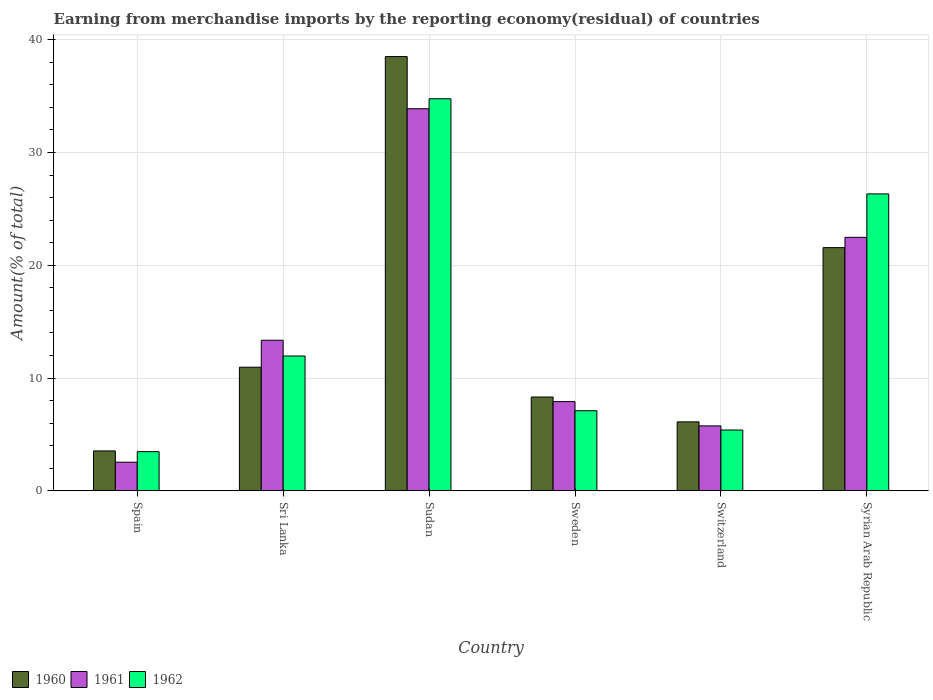Are the number of bars per tick equal to the number of legend labels?
Give a very brief answer. Yes. How many bars are there on the 3rd tick from the left?
Your answer should be very brief. 3. What is the label of the 2nd group of bars from the left?
Provide a short and direct response. Sri Lanka. In how many cases, is the number of bars for a given country not equal to the number of legend labels?
Ensure brevity in your answer.  0. What is the percentage of amount earned from merchandise imports in 1960 in Sudan?
Provide a short and direct response. 38.5. Across all countries, what is the maximum percentage of amount earned from merchandise imports in 1960?
Give a very brief answer. 38.5. Across all countries, what is the minimum percentage of amount earned from merchandise imports in 1961?
Your answer should be compact. 2.54. In which country was the percentage of amount earned from merchandise imports in 1961 maximum?
Provide a succinct answer. Sudan. In which country was the percentage of amount earned from merchandise imports in 1961 minimum?
Your response must be concise. Spain. What is the total percentage of amount earned from merchandise imports in 1962 in the graph?
Provide a succinct answer. 89. What is the difference between the percentage of amount earned from merchandise imports in 1961 in Sri Lanka and that in Sweden?
Your answer should be compact. 5.44. What is the difference between the percentage of amount earned from merchandise imports in 1962 in Sudan and the percentage of amount earned from merchandise imports in 1961 in Sweden?
Ensure brevity in your answer.  26.86. What is the average percentage of amount earned from merchandise imports in 1962 per country?
Keep it short and to the point. 14.83. What is the difference between the percentage of amount earned from merchandise imports of/in 1962 and percentage of amount earned from merchandise imports of/in 1961 in Sweden?
Offer a very short reply. -0.81. In how many countries, is the percentage of amount earned from merchandise imports in 1961 greater than 10 %?
Ensure brevity in your answer.  3. What is the ratio of the percentage of amount earned from merchandise imports in 1960 in Sudan to that in Switzerland?
Make the answer very short. 6.3. What is the difference between the highest and the second highest percentage of amount earned from merchandise imports in 1961?
Your answer should be very brief. 20.53. What is the difference between the highest and the lowest percentage of amount earned from merchandise imports in 1961?
Ensure brevity in your answer.  31.34. In how many countries, is the percentage of amount earned from merchandise imports in 1962 greater than the average percentage of amount earned from merchandise imports in 1962 taken over all countries?
Offer a terse response. 2. Is the sum of the percentage of amount earned from merchandise imports in 1961 in Spain and Sweden greater than the maximum percentage of amount earned from merchandise imports in 1962 across all countries?
Provide a short and direct response. No. What does the 3rd bar from the left in Sudan represents?
Give a very brief answer. 1962. What does the 3rd bar from the right in Sweden represents?
Your answer should be compact. 1960. Are all the bars in the graph horizontal?
Your response must be concise. No. How many countries are there in the graph?
Your answer should be very brief. 6. What is the difference between two consecutive major ticks on the Y-axis?
Provide a succinct answer. 10. Does the graph contain grids?
Give a very brief answer. Yes. Where does the legend appear in the graph?
Your answer should be very brief. Bottom left. How many legend labels are there?
Give a very brief answer. 3. What is the title of the graph?
Make the answer very short. Earning from merchandise imports by the reporting economy(residual) of countries. What is the label or title of the X-axis?
Your answer should be very brief. Country. What is the label or title of the Y-axis?
Offer a terse response. Amount(% of total). What is the Amount(% of total) in 1960 in Spain?
Offer a very short reply. 3.54. What is the Amount(% of total) in 1961 in Spain?
Your answer should be very brief. 2.54. What is the Amount(% of total) of 1962 in Spain?
Offer a very short reply. 3.47. What is the Amount(% of total) in 1960 in Sri Lanka?
Your answer should be very brief. 10.96. What is the Amount(% of total) of 1961 in Sri Lanka?
Ensure brevity in your answer.  13.35. What is the Amount(% of total) in 1962 in Sri Lanka?
Give a very brief answer. 11.95. What is the Amount(% of total) of 1960 in Sudan?
Provide a succinct answer. 38.5. What is the Amount(% of total) of 1961 in Sudan?
Keep it short and to the point. 33.88. What is the Amount(% of total) in 1962 in Sudan?
Make the answer very short. 34.76. What is the Amount(% of total) of 1960 in Sweden?
Keep it short and to the point. 8.32. What is the Amount(% of total) of 1961 in Sweden?
Your answer should be compact. 7.91. What is the Amount(% of total) of 1962 in Sweden?
Provide a succinct answer. 7.1. What is the Amount(% of total) of 1960 in Switzerland?
Ensure brevity in your answer.  6.11. What is the Amount(% of total) of 1961 in Switzerland?
Your answer should be compact. 5.76. What is the Amount(% of total) in 1962 in Switzerland?
Offer a terse response. 5.39. What is the Amount(% of total) in 1960 in Syrian Arab Republic?
Give a very brief answer. 21.56. What is the Amount(% of total) in 1961 in Syrian Arab Republic?
Provide a succinct answer. 22.48. What is the Amount(% of total) in 1962 in Syrian Arab Republic?
Offer a terse response. 26.33. Across all countries, what is the maximum Amount(% of total) in 1960?
Your answer should be compact. 38.5. Across all countries, what is the maximum Amount(% of total) in 1961?
Ensure brevity in your answer.  33.88. Across all countries, what is the maximum Amount(% of total) of 1962?
Your answer should be compact. 34.76. Across all countries, what is the minimum Amount(% of total) of 1960?
Your answer should be very brief. 3.54. Across all countries, what is the minimum Amount(% of total) in 1961?
Your response must be concise. 2.54. Across all countries, what is the minimum Amount(% of total) in 1962?
Make the answer very short. 3.47. What is the total Amount(% of total) in 1960 in the graph?
Offer a very short reply. 88.99. What is the total Amount(% of total) in 1961 in the graph?
Offer a very short reply. 85.9. What is the total Amount(% of total) in 1962 in the graph?
Make the answer very short. 89. What is the difference between the Amount(% of total) of 1960 in Spain and that in Sri Lanka?
Provide a short and direct response. -7.42. What is the difference between the Amount(% of total) in 1961 in Spain and that in Sri Lanka?
Your answer should be very brief. -10.81. What is the difference between the Amount(% of total) in 1962 in Spain and that in Sri Lanka?
Your answer should be very brief. -8.48. What is the difference between the Amount(% of total) of 1960 in Spain and that in Sudan?
Your response must be concise. -34.97. What is the difference between the Amount(% of total) of 1961 in Spain and that in Sudan?
Your response must be concise. -31.34. What is the difference between the Amount(% of total) of 1962 in Spain and that in Sudan?
Your response must be concise. -31.29. What is the difference between the Amount(% of total) in 1960 in Spain and that in Sweden?
Offer a very short reply. -4.78. What is the difference between the Amount(% of total) of 1961 in Spain and that in Sweden?
Your response must be concise. -5.37. What is the difference between the Amount(% of total) of 1962 in Spain and that in Sweden?
Offer a terse response. -3.63. What is the difference between the Amount(% of total) in 1960 in Spain and that in Switzerland?
Provide a short and direct response. -2.58. What is the difference between the Amount(% of total) in 1961 in Spain and that in Switzerland?
Give a very brief answer. -3.22. What is the difference between the Amount(% of total) of 1962 in Spain and that in Switzerland?
Offer a very short reply. -1.92. What is the difference between the Amount(% of total) of 1960 in Spain and that in Syrian Arab Republic?
Your answer should be compact. -18.03. What is the difference between the Amount(% of total) of 1961 in Spain and that in Syrian Arab Republic?
Your response must be concise. -19.94. What is the difference between the Amount(% of total) of 1962 in Spain and that in Syrian Arab Republic?
Provide a succinct answer. -22.86. What is the difference between the Amount(% of total) of 1960 in Sri Lanka and that in Sudan?
Give a very brief answer. -27.55. What is the difference between the Amount(% of total) of 1961 in Sri Lanka and that in Sudan?
Provide a short and direct response. -20.53. What is the difference between the Amount(% of total) of 1962 in Sri Lanka and that in Sudan?
Offer a very short reply. -22.81. What is the difference between the Amount(% of total) in 1960 in Sri Lanka and that in Sweden?
Offer a very short reply. 2.64. What is the difference between the Amount(% of total) of 1961 in Sri Lanka and that in Sweden?
Make the answer very short. 5.44. What is the difference between the Amount(% of total) of 1962 in Sri Lanka and that in Sweden?
Make the answer very short. 4.85. What is the difference between the Amount(% of total) in 1960 in Sri Lanka and that in Switzerland?
Make the answer very short. 4.85. What is the difference between the Amount(% of total) in 1961 in Sri Lanka and that in Switzerland?
Make the answer very short. 7.59. What is the difference between the Amount(% of total) of 1962 in Sri Lanka and that in Switzerland?
Keep it short and to the point. 6.56. What is the difference between the Amount(% of total) of 1960 in Sri Lanka and that in Syrian Arab Republic?
Offer a terse response. -10.61. What is the difference between the Amount(% of total) of 1961 in Sri Lanka and that in Syrian Arab Republic?
Ensure brevity in your answer.  -9.13. What is the difference between the Amount(% of total) in 1962 in Sri Lanka and that in Syrian Arab Republic?
Keep it short and to the point. -14.37. What is the difference between the Amount(% of total) of 1960 in Sudan and that in Sweden?
Give a very brief answer. 30.19. What is the difference between the Amount(% of total) in 1961 in Sudan and that in Sweden?
Provide a short and direct response. 25.97. What is the difference between the Amount(% of total) of 1962 in Sudan and that in Sweden?
Offer a terse response. 27.66. What is the difference between the Amount(% of total) of 1960 in Sudan and that in Switzerland?
Provide a succinct answer. 32.39. What is the difference between the Amount(% of total) of 1961 in Sudan and that in Switzerland?
Make the answer very short. 28.12. What is the difference between the Amount(% of total) of 1962 in Sudan and that in Switzerland?
Give a very brief answer. 29.37. What is the difference between the Amount(% of total) in 1960 in Sudan and that in Syrian Arab Republic?
Give a very brief answer. 16.94. What is the difference between the Amount(% of total) in 1961 in Sudan and that in Syrian Arab Republic?
Offer a very short reply. 11.4. What is the difference between the Amount(% of total) of 1962 in Sudan and that in Syrian Arab Republic?
Make the answer very short. 8.44. What is the difference between the Amount(% of total) in 1960 in Sweden and that in Switzerland?
Offer a terse response. 2.2. What is the difference between the Amount(% of total) of 1961 in Sweden and that in Switzerland?
Offer a terse response. 2.15. What is the difference between the Amount(% of total) of 1962 in Sweden and that in Switzerland?
Ensure brevity in your answer.  1.71. What is the difference between the Amount(% of total) of 1960 in Sweden and that in Syrian Arab Republic?
Give a very brief answer. -13.25. What is the difference between the Amount(% of total) in 1961 in Sweden and that in Syrian Arab Republic?
Give a very brief answer. -14.57. What is the difference between the Amount(% of total) in 1962 in Sweden and that in Syrian Arab Republic?
Make the answer very short. -19.23. What is the difference between the Amount(% of total) of 1960 in Switzerland and that in Syrian Arab Republic?
Make the answer very short. -15.45. What is the difference between the Amount(% of total) in 1961 in Switzerland and that in Syrian Arab Republic?
Your answer should be compact. -16.72. What is the difference between the Amount(% of total) in 1962 in Switzerland and that in Syrian Arab Republic?
Provide a succinct answer. -20.94. What is the difference between the Amount(% of total) of 1960 in Spain and the Amount(% of total) of 1961 in Sri Lanka?
Make the answer very short. -9.81. What is the difference between the Amount(% of total) of 1960 in Spain and the Amount(% of total) of 1962 in Sri Lanka?
Give a very brief answer. -8.42. What is the difference between the Amount(% of total) in 1961 in Spain and the Amount(% of total) in 1962 in Sri Lanka?
Offer a very short reply. -9.42. What is the difference between the Amount(% of total) of 1960 in Spain and the Amount(% of total) of 1961 in Sudan?
Provide a short and direct response. -30.34. What is the difference between the Amount(% of total) in 1960 in Spain and the Amount(% of total) in 1962 in Sudan?
Give a very brief answer. -31.23. What is the difference between the Amount(% of total) of 1961 in Spain and the Amount(% of total) of 1962 in Sudan?
Keep it short and to the point. -32.23. What is the difference between the Amount(% of total) in 1960 in Spain and the Amount(% of total) in 1961 in Sweden?
Give a very brief answer. -4.37. What is the difference between the Amount(% of total) of 1960 in Spain and the Amount(% of total) of 1962 in Sweden?
Offer a very short reply. -3.56. What is the difference between the Amount(% of total) of 1961 in Spain and the Amount(% of total) of 1962 in Sweden?
Provide a succinct answer. -4.56. What is the difference between the Amount(% of total) in 1960 in Spain and the Amount(% of total) in 1961 in Switzerland?
Offer a terse response. -2.22. What is the difference between the Amount(% of total) in 1960 in Spain and the Amount(% of total) in 1962 in Switzerland?
Your answer should be compact. -1.85. What is the difference between the Amount(% of total) of 1961 in Spain and the Amount(% of total) of 1962 in Switzerland?
Ensure brevity in your answer.  -2.85. What is the difference between the Amount(% of total) of 1960 in Spain and the Amount(% of total) of 1961 in Syrian Arab Republic?
Keep it short and to the point. -18.94. What is the difference between the Amount(% of total) of 1960 in Spain and the Amount(% of total) of 1962 in Syrian Arab Republic?
Keep it short and to the point. -22.79. What is the difference between the Amount(% of total) of 1961 in Spain and the Amount(% of total) of 1962 in Syrian Arab Republic?
Provide a succinct answer. -23.79. What is the difference between the Amount(% of total) in 1960 in Sri Lanka and the Amount(% of total) in 1961 in Sudan?
Make the answer very short. -22.92. What is the difference between the Amount(% of total) in 1960 in Sri Lanka and the Amount(% of total) in 1962 in Sudan?
Keep it short and to the point. -23.8. What is the difference between the Amount(% of total) in 1961 in Sri Lanka and the Amount(% of total) in 1962 in Sudan?
Make the answer very short. -21.41. What is the difference between the Amount(% of total) in 1960 in Sri Lanka and the Amount(% of total) in 1961 in Sweden?
Your answer should be very brief. 3.05. What is the difference between the Amount(% of total) in 1960 in Sri Lanka and the Amount(% of total) in 1962 in Sweden?
Make the answer very short. 3.86. What is the difference between the Amount(% of total) of 1961 in Sri Lanka and the Amount(% of total) of 1962 in Sweden?
Ensure brevity in your answer.  6.25. What is the difference between the Amount(% of total) of 1960 in Sri Lanka and the Amount(% of total) of 1961 in Switzerland?
Offer a very short reply. 5.2. What is the difference between the Amount(% of total) of 1960 in Sri Lanka and the Amount(% of total) of 1962 in Switzerland?
Give a very brief answer. 5.57. What is the difference between the Amount(% of total) of 1961 in Sri Lanka and the Amount(% of total) of 1962 in Switzerland?
Ensure brevity in your answer.  7.96. What is the difference between the Amount(% of total) in 1960 in Sri Lanka and the Amount(% of total) in 1961 in Syrian Arab Republic?
Make the answer very short. -11.52. What is the difference between the Amount(% of total) of 1960 in Sri Lanka and the Amount(% of total) of 1962 in Syrian Arab Republic?
Offer a terse response. -15.37. What is the difference between the Amount(% of total) in 1961 in Sri Lanka and the Amount(% of total) in 1962 in Syrian Arab Republic?
Keep it short and to the point. -12.98. What is the difference between the Amount(% of total) in 1960 in Sudan and the Amount(% of total) in 1961 in Sweden?
Your answer should be compact. 30.6. What is the difference between the Amount(% of total) in 1960 in Sudan and the Amount(% of total) in 1962 in Sweden?
Offer a terse response. 31.4. What is the difference between the Amount(% of total) in 1961 in Sudan and the Amount(% of total) in 1962 in Sweden?
Give a very brief answer. 26.78. What is the difference between the Amount(% of total) in 1960 in Sudan and the Amount(% of total) in 1961 in Switzerland?
Provide a short and direct response. 32.75. What is the difference between the Amount(% of total) of 1960 in Sudan and the Amount(% of total) of 1962 in Switzerland?
Make the answer very short. 33.11. What is the difference between the Amount(% of total) of 1961 in Sudan and the Amount(% of total) of 1962 in Switzerland?
Offer a very short reply. 28.49. What is the difference between the Amount(% of total) of 1960 in Sudan and the Amount(% of total) of 1961 in Syrian Arab Republic?
Your answer should be very brief. 16.03. What is the difference between the Amount(% of total) in 1960 in Sudan and the Amount(% of total) in 1962 in Syrian Arab Republic?
Provide a short and direct response. 12.18. What is the difference between the Amount(% of total) of 1961 in Sudan and the Amount(% of total) of 1962 in Syrian Arab Republic?
Provide a short and direct response. 7.55. What is the difference between the Amount(% of total) in 1960 in Sweden and the Amount(% of total) in 1961 in Switzerland?
Offer a very short reply. 2.56. What is the difference between the Amount(% of total) in 1960 in Sweden and the Amount(% of total) in 1962 in Switzerland?
Provide a short and direct response. 2.93. What is the difference between the Amount(% of total) of 1961 in Sweden and the Amount(% of total) of 1962 in Switzerland?
Offer a very short reply. 2.52. What is the difference between the Amount(% of total) of 1960 in Sweden and the Amount(% of total) of 1961 in Syrian Arab Republic?
Your answer should be very brief. -14.16. What is the difference between the Amount(% of total) in 1960 in Sweden and the Amount(% of total) in 1962 in Syrian Arab Republic?
Offer a very short reply. -18.01. What is the difference between the Amount(% of total) of 1961 in Sweden and the Amount(% of total) of 1962 in Syrian Arab Republic?
Ensure brevity in your answer.  -18.42. What is the difference between the Amount(% of total) in 1960 in Switzerland and the Amount(% of total) in 1961 in Syrian Arab Republic?
Make the answer very short. -16.36. What is the difference between the Amount(% of total) of 1960 in Switzerland and the Amount(% of total) of 1962 in Syrian Arab Republic?
Ensure brevity in your answer.  -20.21. What is the difference between the Amount(% of total) in 1961 in Switzerland and the Amount(% of total) in 1962 in Syrian Arab Republic?
Ensure brevity in your answer.  -20.57. What is the average Amount(% of total) in 1960 per country?
Give a very brief answer. 14.83. What is the average Amount(% of total) in 1961 per country?
Ensure brevity in your answer.  14.32. What is the average Amount(% of total) in 1962 per country?
Offer a very short reply. 14.83. What is the difference between the Amount(% of total) in 1960 and Amount(% of total) in 1961 in Spain?
Your response must be concise. 1. What is the difference between the Amount(% of total) of 1960 and Amount(% of total) of 1962 in Spain?
Your response must be concise. 0.07. What is the difference between the Amount(% of total) of 1961 and Amount(% of total) of 1962 in Spain?
Make the answer very short. -0.94. What is the difference between the Amount(% of total) in 1960 and Amount(% of total) in 1961 in Sri Lanka?
Offer a very short reply. -2.39. What is the difference between the Amount(% of total) of 1960 and Amount(% of total) of 1962 in Sri Lanka?
Keep it short and to the point. -0.99. What is the difference between the Amount(% of total) of 1961 and Amount(% of total) of 1962 in Sri Lanka?
Your answer should be very brief. 1.4. What is the difference between the Amount(% of total) of 1960 and Amount(% of total) of 1961 in Sudan?
Your response must be concise. 4.63. What is the difference between the Amount(% of total) in 1960 and Amount(% of total) in 1962 in Sudan?
Keep it short and to the point. 3.74. What is the difference between the Amount(% of total) in 1961 and Amount(% of total) in 1962 in Sudan?
Your answer should be compact. -0.89. What is the difference between the Amount(% of total) in 1960 and Amount(% of total) in 1961 in Sweden?
Offer a terse response. 0.41. What is the difference between the Amount(% of total) of 1960 and Amount(% of total) of 1962 in Sweden?
Make the answer very short. 1.22. What is the difference between the Amount(% of total) in 1961 and Amount(% of total) in 1962 in Sweden?
Offer a terse response. 0.81. What is the difference between the Amount(% of total) in 1960 and Amount(% of total) in 1961 in Switzerland?
Keep it short and to the point. 0.36. What is the difference between the Amount(% of total) in 1960 and Amount(% of total) in 1962 in Switzerland?
Keep it short and to the point. 0.72. What is the difference between the Amount(% of total) of 1961 and Amount(% of total) of 1962 in Switzerland?
Provide a succinct answer. 0.37. What is the difference between the Amount(% of total) in 1960 and Amount(% of total) in 1961 in Syrian Arab Republic?
Ensure brevity in your answer.  -0.91. What is the difference between the Amount(% of total) in 1960 and Amount(% of total) in 1962 in Syrian Arab Republic?
Offer a terse response. -4.76. What is the difference between the Amount(% of total) of 1961 and Amount(% of total) of 1962 in Syrian Arab Republic?
Your answer should be compact. -3.85. What is the ratio of the Amount(% of total) of 1960 in Spain to that in Sri Lanka?
Your response must be concise. 0.32. What is the ratio of the Amount(% of total) in 1961 in Spain to that in Sri Lanka?
Offer a very short reply. 0.19. What is the ratio of the Amount(% of total) of 1962 in Spain to that in Sri Lanka?
Your response must be concise. 0.29. What is the ratio of the Amount(% of total) in 1960 in Spain to that in Sudan?
Provide a succinct answer. 0.09. What is the ratio of the Amount(% of total) of 1961 in Spain to that in Sudan?
Your response must be concise. 0.07. What is the ratio of the Amount(% of total) in 1962 in Spain to that in Sudan?
Keep it short and to the point. 0.1. What is the ratio of the Amount(% of total) of 1960 in Spain to that in Sweden?
Your response must be concise. 0.43. What is the ratio of the Amount(% of total) in 1961 in Spain to that in Sweden?
Offer a terse response. 0.32. What is the ratio of the Amount(% of total) of 1962 in Spain to that in Sweden?
Provide a succinct answer. 0.49. What is the ratio of the Amount(% of total) in 1960 in Spain to that in Switzerland?
Provide a succinct answer. 0.58. What is the ratio of the Amount(% of total) in 1961 in Spain to that in Switzerland?
Ensure brevity in your answer.  0.44. What is the ratio of the Amount(% of total) of 1962 in Spain to that in Switzerland?
Offer a very short reply. 0.64. What is the ratio of the Amount(% of total) in 1960 in Spain to that in Syrian Arab Republic?
Offer a very short reply. 0.16. What is the ratio of the Amount(% of total) of 1961 in Spain to that in Syrian Arab Republic?
Your response must be concise. 0.11. What is the ratio of the Amount(% of total) in 1962 in Spain to that in Syrian Arab Republic?
Make the answer very short. 0.13. What is the ratio of the Amount(% of total) of 1960 in Sri Lanka to that in Sudan?
Offer a very short reply. 0.28. What is the ratio of the Amount(% of total) in 1961 in Sri Lanka to that in Sudan?
Provide a short and direct response. 0.39. What is the ratio of the Amount(% of total) of 1962 in Sri Lanka to that in Sudan?
Provide a succinct answer. 0.34. What is the ratio of the Amount(% of total) in 1960 in Sri Lanka to that in Sweden?
Make the answer very short. 1.32. What is the ratio of the Amount(% of total) of 1961 in Sri Lanka to that in Sweden?
Provide a succinct answer. 1.69. What is the ratio of the Amount(% of total) of 1962 in Sri Lanka to that in Sweden?
Provide a succinct answer. 1.68. What is the ratio of the Amount(% of total) of 1960 in Sri Lanka to that in Switzerland?
Keep it short and to the point. 1.79. What is the ratio of the Amount(% of total) in 1961 in Sri Lanka to that in Switzerland?
Ensure brevity in your answer.  2.32. What is the ratio of the Amount(% of total) of 1962 in Sri Lanka to that in Switzerland?
Give a very brief answer. 2.22. What is the ratio of the Amount(% of total) of 1960 in Sri Lanka to that in Syrian Arab Republic?
Give a very brief answer. 0.51. What is the ratio of the Amount(% of total) in 1961 in Sri Lanka to that in Syrian Arab Republic?
Keep it short and to the point. 0.59. What is the ratio of the Amount(% of total) of 1962 in Sri Lanka to that in Syrian Arab Republic?
Ensure brevity in your answer.  0.45. What is the ratio of the Amount(% of total) in 1960 in Sudan to that in Sweden?
Your response must be concise. 4.63. What is the ratio of the Amount(% of total) in 1961 in Sudan to that in Sweden?
Provide a succinct answer. 4.28. What is the ratio of the Amount(% of total) in 1962 in Sudan to that in Sweden?
Provide a succinct answer. 4.9. What is the ratio of the Amount(% of total) of 1960 in Sudan to that in Switzerland?
Ensure brevity in your answer.  6.3. What is the ratio of the Amount(% of total) in 1961 in Sudan to that in Switzerland?
Make the answer very short. 5.89. What is the ratio of the Amount(% of total) of 1962 in Sudan to that in Switzerland?
Your response must be concise. 6.45. What is the ratio of the Amount(% of total) in 1960 in Sudan to that in Syrian Arab Republic?
Provide a short and direct response. 1.79. What is the ratio of the Amount(% of total) in 1961 in Sudan to that in Syrian Arab Republic?
Give a very brief answer. 1.51. What is the ratio of the Amount(% of total) of 1962 in Sudan to that in Syrian Arab Republic?
Your answer should be very brief. 1.32. What is the ratio of the Amount(% of total) of 1960 in Sweden to that in Switzerland?
Offer a terse response. 1.36. What is the ratio of the Amount(% of total) in 1961 in Sweden to that in Switzerland?
Make the answer very short. 1.37. What is the ratio of the Amount(% of total) in 1962 in Sweden to that in Switzerland?
Your response must be concise. 1.32. What is the ratio of the Amount(% of total) of 1960 in Sweden to that in Syrian Arab Republic?
Your response must be concise. 0.39. What is the ratio of the Amount(% of total) in 1961 in Sweden to that in Syrian Arab Republic?
Ensure brevity in your answer.  0.35. What is the ratio of the Amount(% of total) of 1962 in Sweden to that in Syrian Arab Republic?
Keep it short and to the point. 0.27. What is the ratio of the Amount(% of total) of 1960 in Switzerland to that in Syrian Arab Republic?
Provide a succinct answer. 0.28. What is the ratio of the Amount(% of total) of 1961 in Switzerland to that in Syrian Arab Republic?
Your response must be concise. 0.26. What is the ratio of the Amount(% of total) in 1962 in Switzerland to that in Syrian Arab Republic?
Your response must be concise. 0.2. What is the difference between the highest and the second highest Amount(% of total) in 1960?
Make the answer very short. 16.94. What is the difference between the highest and the second highest Amount(% of total) in 1961?
Your response must be concise. 11.4. What is the difference between the highest and the second highest Amount(% of total) in 1962?
Ensure brevity in your answer.  8.44. What is the difference between the highest and the lowest Amount(% of total) in 1960?
Keep it short and to the point. 34.97. What is the difference between the highest and the lowest Amount(% of total) of 1961?
Give a very brief answer. 31.34. What is the difference between the highest and the lowest Amount(% of total) in 1962?
Provide a succinct answer. 31.29. 